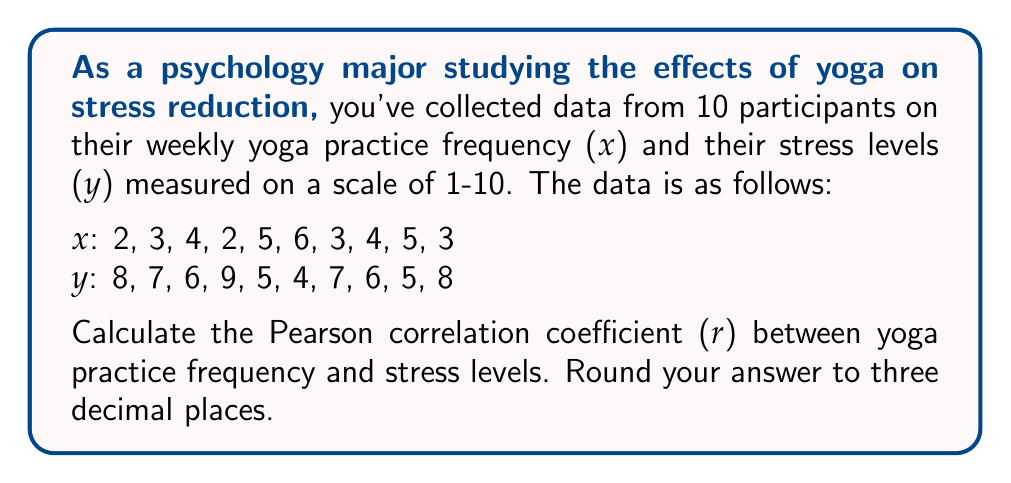What is the answer to this math problem? To calculate the Pearson correlation coefficient (r), we'll use the formula:

$$ r = \frac{n\sum xy - \sum x \sum y}{\sqrt{[n\sum x^2 - (\sum x)^2][n\sum y^2 - (\sum y)^2]}} $$

Let's break it down step-by-step:

1. Calculate the sums and squares:
   $\sum x = 37$
   $\sum y = 65$
   $\sum xy = 229$
   $\sum x^2 = 153$
   $\sum y^2 = 449$
   $n = 10$

2. Calculate $n\sum xy$:
   $10 \times 229 = 2290$

3. Calculate $\sum x \sum y$:
   $37 \times 65 = 2405$

4. Calculate the numerator:
   $2290 - 2405 = -115$

5. Calculate $n\sum x^2$ and $(\sum x)^2$:
   $10 \times 153 = 1530$
   $37^2 = 1369$

6. Calculate $n\sum y^2$ and $(\sum y)^2$:
   $10 \times 449 = 4490$
   $65^2 = 4225$

7. Calculate the denominator:
   $\sqrt{(1530 - 1369)(4490 - 4225)} = \sqrt{161 \times 265} = \sqrt{42665} \approx 206.55$

8. Divide the numerator by the denominator:
   $\frac{-115}{206.55} \approx -0.557$

9. Round to three decimal places:
   $-0.557$
Answer: $-0.557$ 